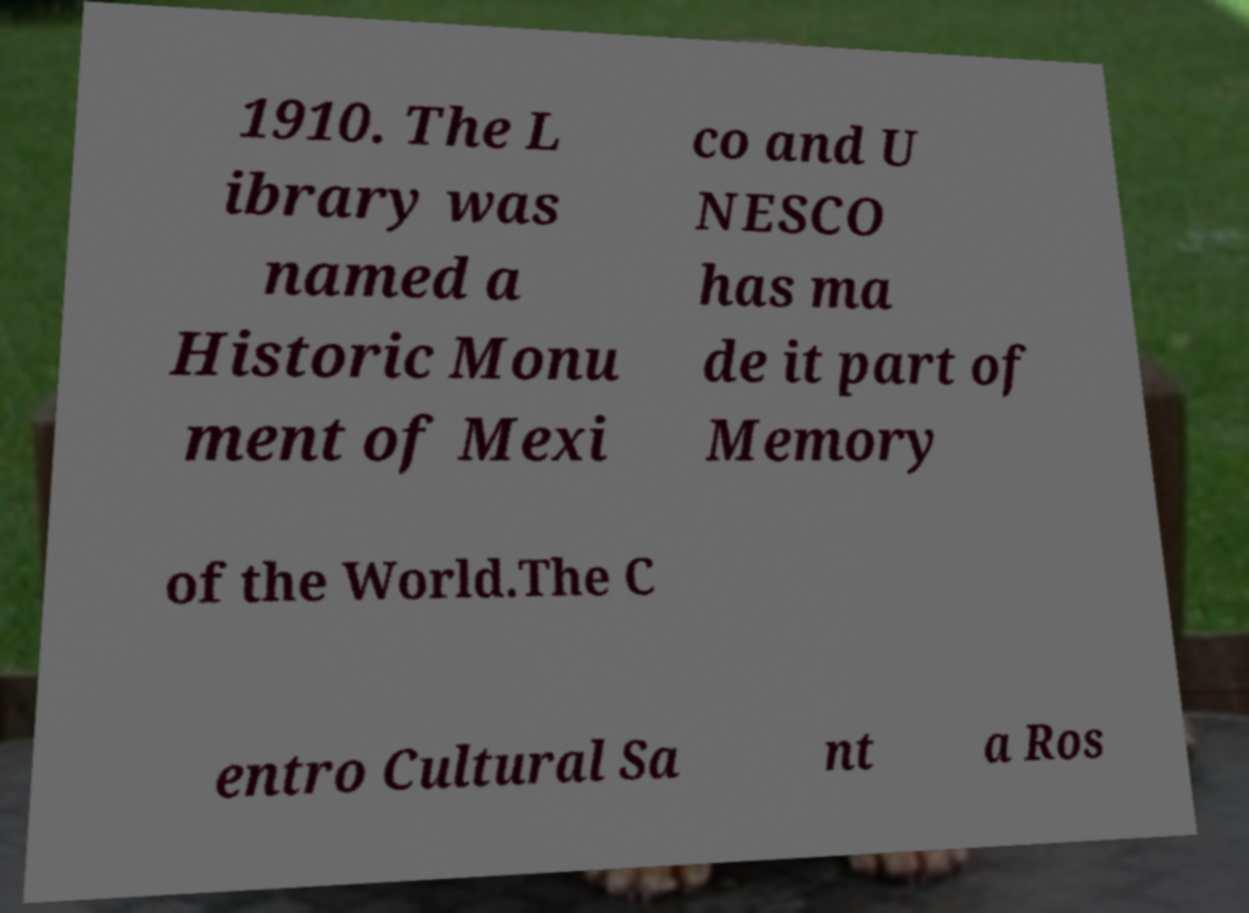For documentation purposes, I need the text within this image transcribed. Could you provide that? 1910. The L ibrary was named a Historic Monu ment of Mexi co and U NESCO has ma de it part of Memory of the World.The C entro Cultural Sa nt a Ros 